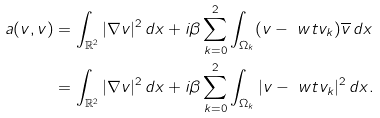<formula> <loc_0><loc_0><loc_500><loc_500>a ( v , v ) & = \int _ { \mathbb { R } ^ { 2 } } | \nabla v | ^ { 2 } \, d x + i \beta \sum _ { k = 0 } ^ { 2 } \int _ { \Omega _ { k } } ( v - \ w t v _ { k } ) \overline { v } \, d x \\ & = \int _ { \mathbb { R } ^ { 2 } } | \nabla v | ^ { 2 } \, d x + i \beta \sum _ { k = 0 } ^ { 2 } \int _ { \Omega _ { k } } | v - \ w t v _ { k } | ^ { 2 } \, d x .</formula> 